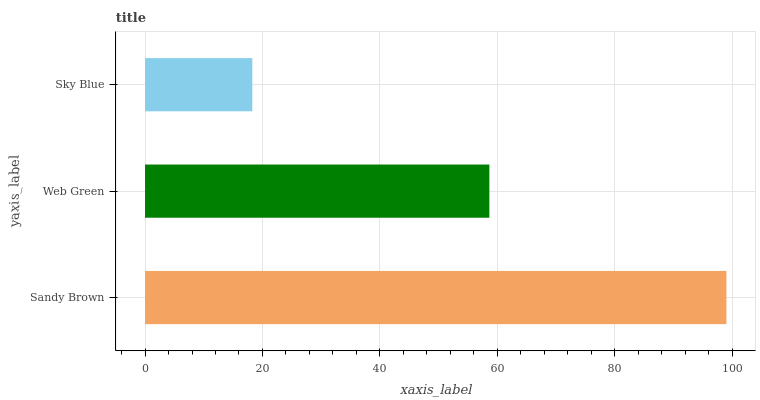Is Sky Blue the minimum?
Answer yes or no. Yes. Is Sandy Brown the maximum?
Answer yes or no. Yes. Is Web Green the minimum?
Answer yes or no. No. Is Web Green the maximum?
Answer yes or no. No. Is Sandy Brown greater than Web Green?
Answer yes or no. Yes. Is Web Green less than Sandy Brown?
Answer yes or no. Yes. Is Web Green greater than Sandy Brown?
Answer yes or no. No. Is Sandy Brown less than Web Green?
Answer yes or no. No. Is Web Green the high median?
Answer yes or no. Yes. Is Web Green the low median?
Answer yes or no. Yes. Is Sky Blue the high median?
Answer yes or no. No. Is Sky Blue the low median?
Answer yes or no. No. 